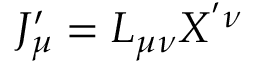<formula> <loc_0><loc_0><loc_500><loc_500>J _ { \mu } ^ { \prime } = L _ { \mu \nu } X ^ { ^ { \prime } \nu }</formula> 